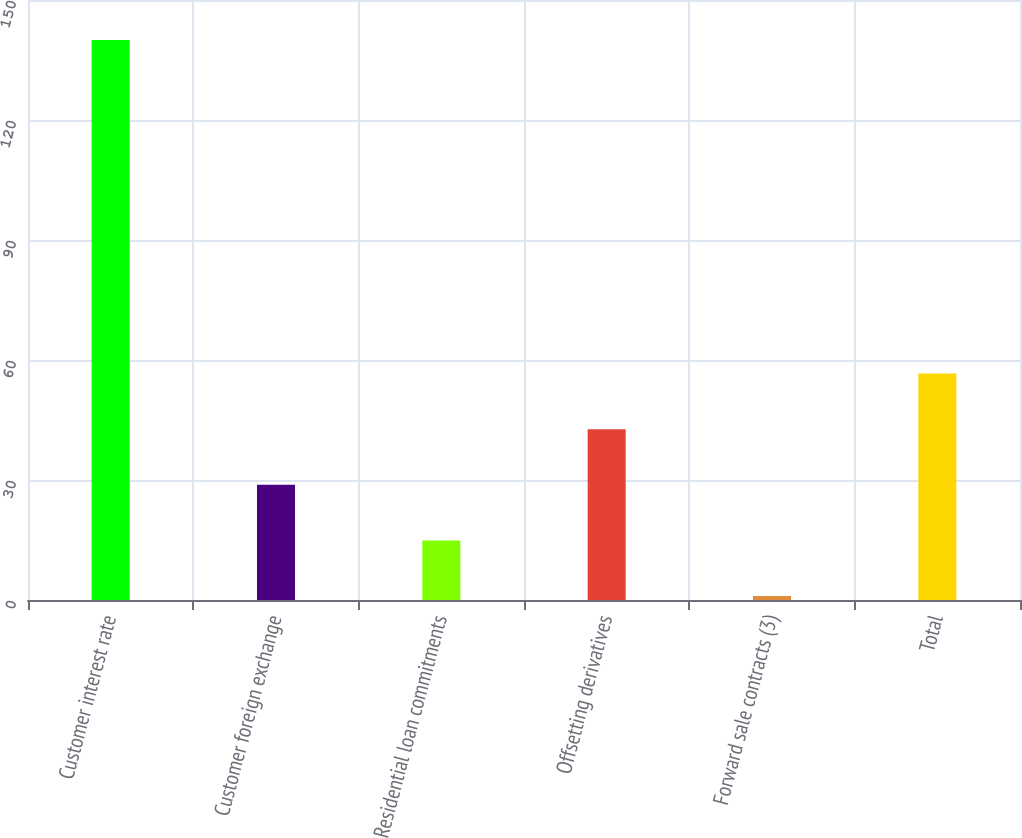Convert chart. <chart><loc_0><loc_0><loc_500><loc_500><bar_chart><fcel>Customer interest rate<fcel>Customer foreign exchange<fcel>Residential loan commitments<fcel>Offsetting derivatives<fcel>Forward sale contracts (3)<fcel>Total<nl><fcel>140<fcel>28.8<fcel>14.9<fcel>42.7<fcel>1<fcel>56.6<nl></chart> 